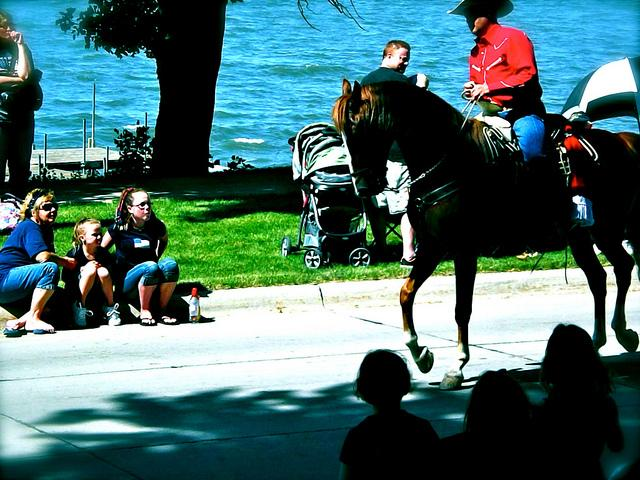The Horse and rider here are part of what? parade 